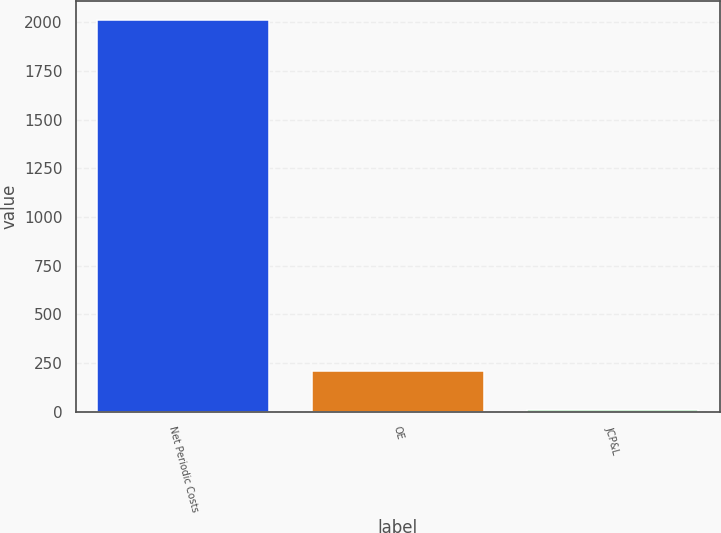Convert chart to OTSL. <chart><loc_0><loc_0><loc_500><loc_500><bar_chart><fcel>Net Periodic Costs<fcel>OE<fcel>JCP&L<nl><fcel>2010<fcel>210<fcel>10<nl></chart> 